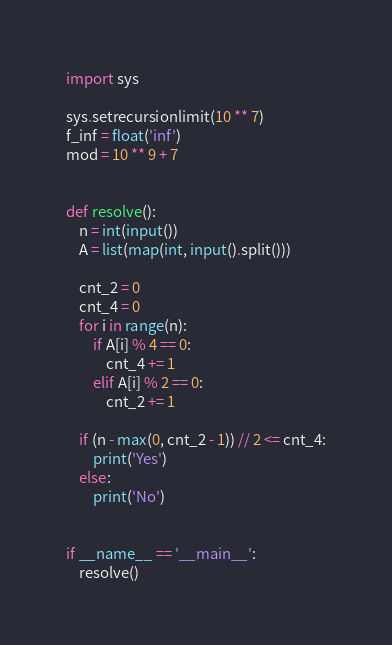Convert code to text. <code><loc_0><loc_0><loc_500><loc_500><_Python_>import sys

sys.setrecursionlimit(10 ** 7)
f_inf = float('inf')
mod = 10 ** 9 + 7


def resolve():
    n = int(input())
    A = list(map(int, input().split()))

    cnt_2 = 0
    cnt_4 = 0
    for i in range(n):
        if A[i] % 4 == 0:
            cnt_4 += 1
        elif A[i] % 2 == 0:
            cnt_2 += 1

    if (n - max(0, cnt_2 - 1)) // 2 <= cnt_4:
        print('Yes')
    else:
        print('No')


if __name__ == '__main__':
    resolve()
</code> 